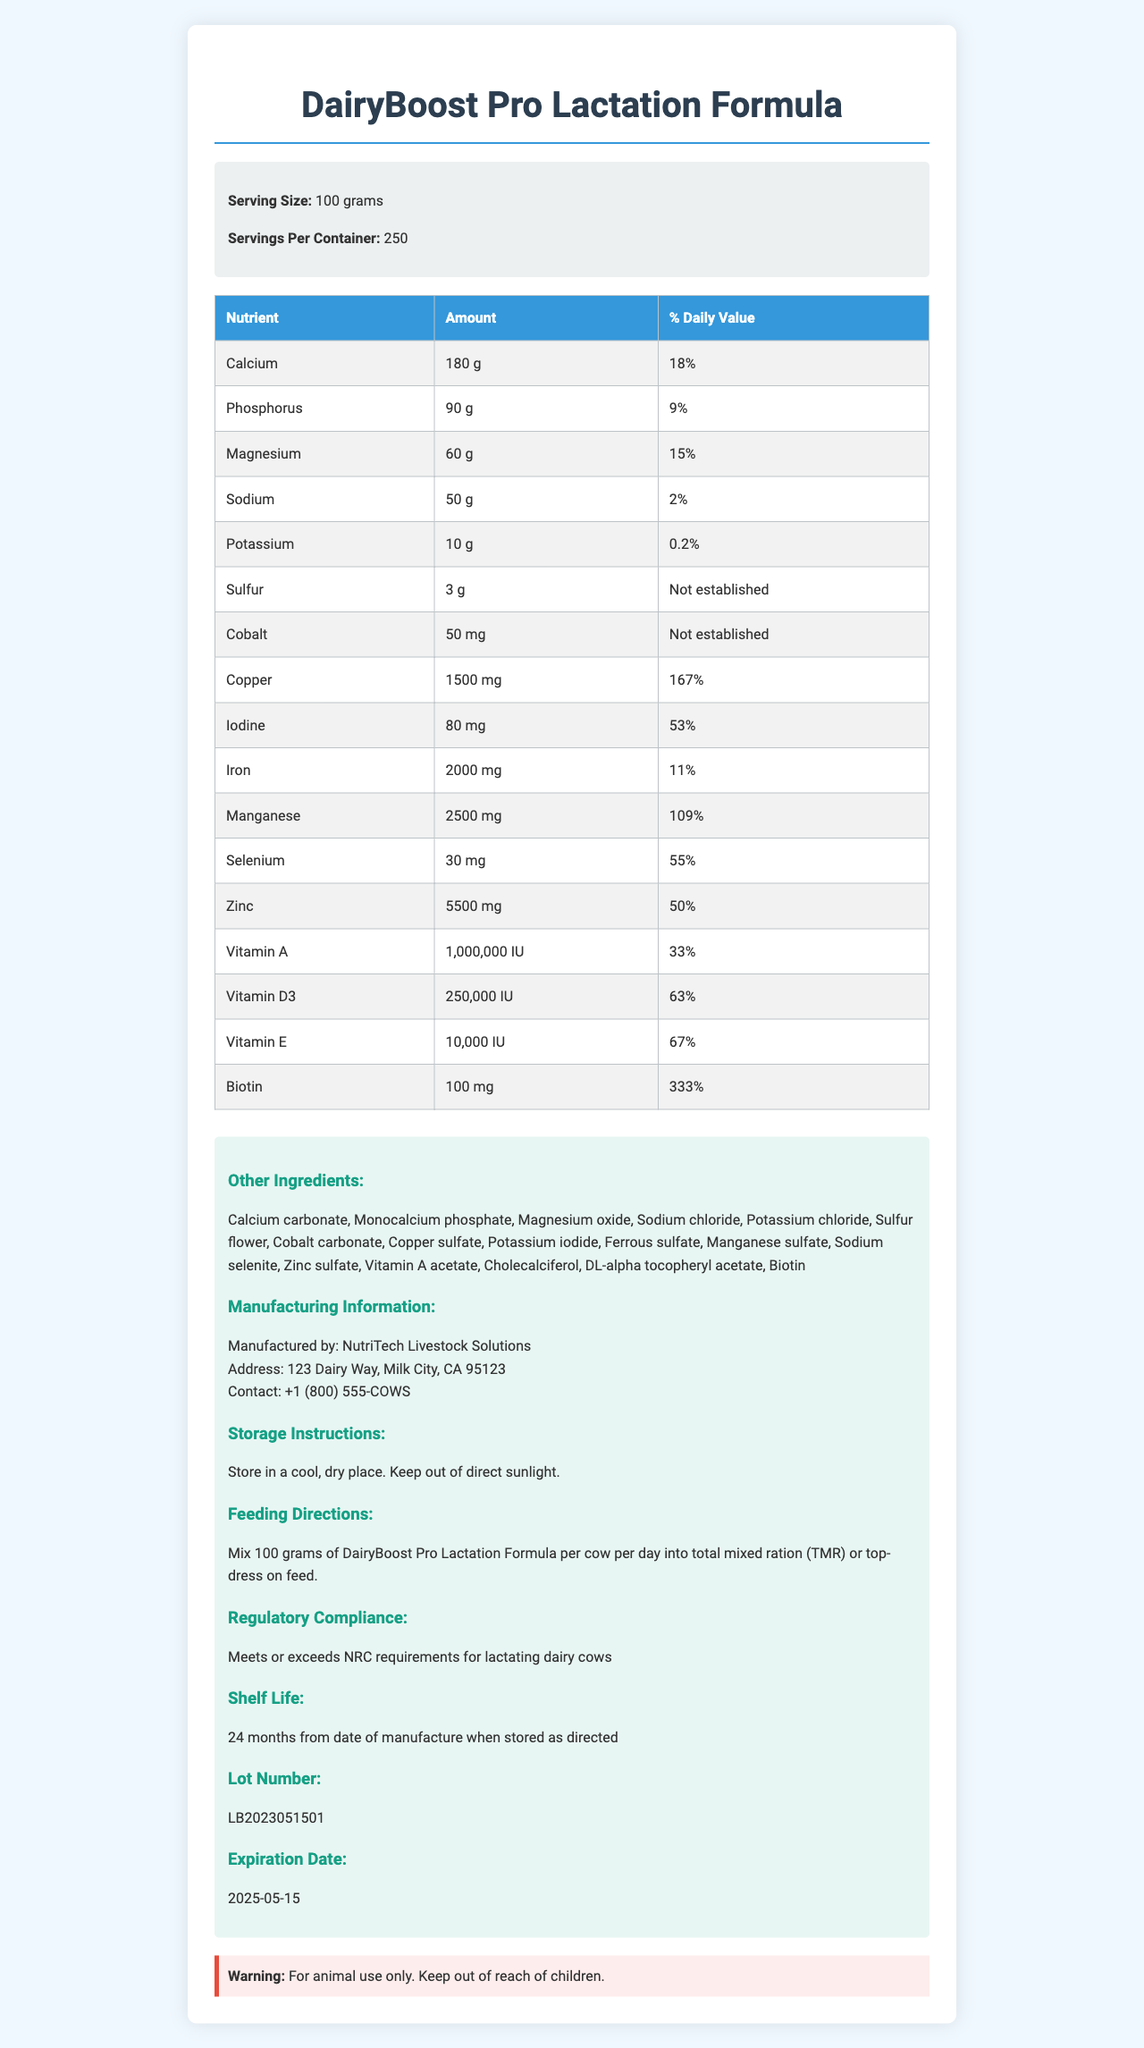what is the serving size? The serving size is listed in the product information section as 100 grams.
Answer: 100 grams how many servings per container are there? The document states that there are 250 servings per container.
Answer: 250 servings which nutrient has the highest daily value percentage? The nutrient table shows that Biotin has the highest daily value percentage with 333%.
Answer: Biotin what is the amount of calcium per serving? The nutrient table lists that one serving contains 180 grams of Calcium.
Answer: 180 grams what is the manufacturing address? The manufacturing information section provides the address as 123 Dairy Way, Milk City, CA 95123.
Answer: 123 Dairy Way, Milk City, CA 95123 which of the following nutrients is not present in DairyBoost Pro Lactation Formula? A. Calcium B. Vitamin C C. Iron D. Zinc The nutrient table lists Calcium, Iron, and Zinc, but not Vitamin C.
Answer: B. Vitamin C what is the contact phone number for NutriTech Livestock Solutions? The manufacturing information section states the contact phone number as +1 (800) 555-COWS.
Answer: +1 (800) 555-COWS is the product compliant with regulatory standards? The regulatory compliance section states that the product meets or exceeds NRC requirements for lactating dairy cows.
Answer: Yes what should you do if you need more information about the feeding directions? The document clearly provides feeding directions in the relevant section, suggesting users should refer there.
Answer: Refer to the feeding directions section how long is the shelf life of the product? The shelf life section states that the product has a shelf life of 24 months from the date of manufacture when stored as directed.
Answer: 24 months describe the DairyBoost Pro Lactation Formula document. The document is comprehensive, covering nutritional details, additional ingredients, manufacturing details, usage instructions, compliance regulations, and warnings, helping users understand the product better.
Answer: The document provides detailed information about DairyBoost Pro Lactation Formula, including serving size, nutrient amounts, and daily values. It also lists other ingredients, manufacturing information, storage instructions, feeding directions, regulatory compliance, shelf life, lot number, and expiration date. The document also includes a warning statement for the product. which nutrient has an established daily value percentage? All the nutrients in the table have a listed daily value percentage except for Sulfur and Cobalt, for which the % Daily Value is not established.
Answer: Cannot be determined 